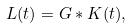Convert formula to latex. <formula><loc_0><loc_0><loc_500><loc_500>L ( t ) = G \ast K ( t ) ,</formula> 